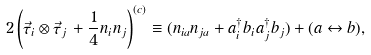<formula> <loc_0><loc_0><loc_500><loc_500>2 \left ( { \vec { \tau } } _ { i } \otimes { \vec { \tau } } _ { j } \, + \frac { 1 } { 4 } n _ { i } n _ { j } \right ) ^ { ( c ) } \equiv ( n _ { i a } n _ { j a } + a _ { i } ^ { \dagger } b _ { i } a _ { j } ^ { \dagger } b _ { j } ) + ( a \leftrightarrow b ) ,</formula> 